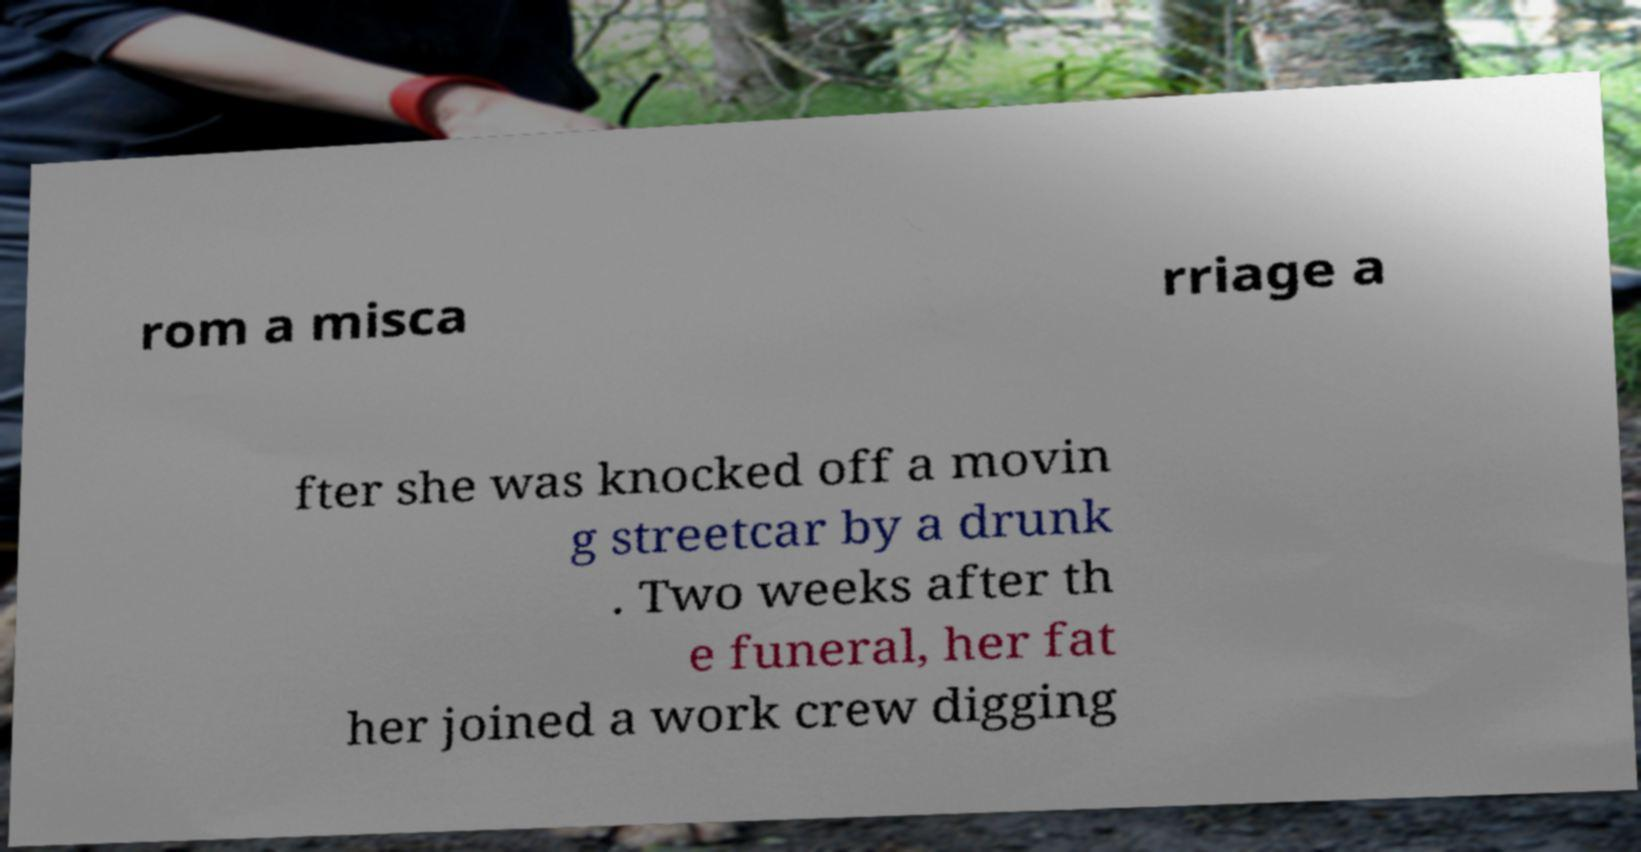Please read and relay the text visible in this image. What does it say? rom a misca rriage a fter she was knocked off a movin g streetcar by a drunk . Two weeks after th e funeral, her fat her joined a work crew digging 